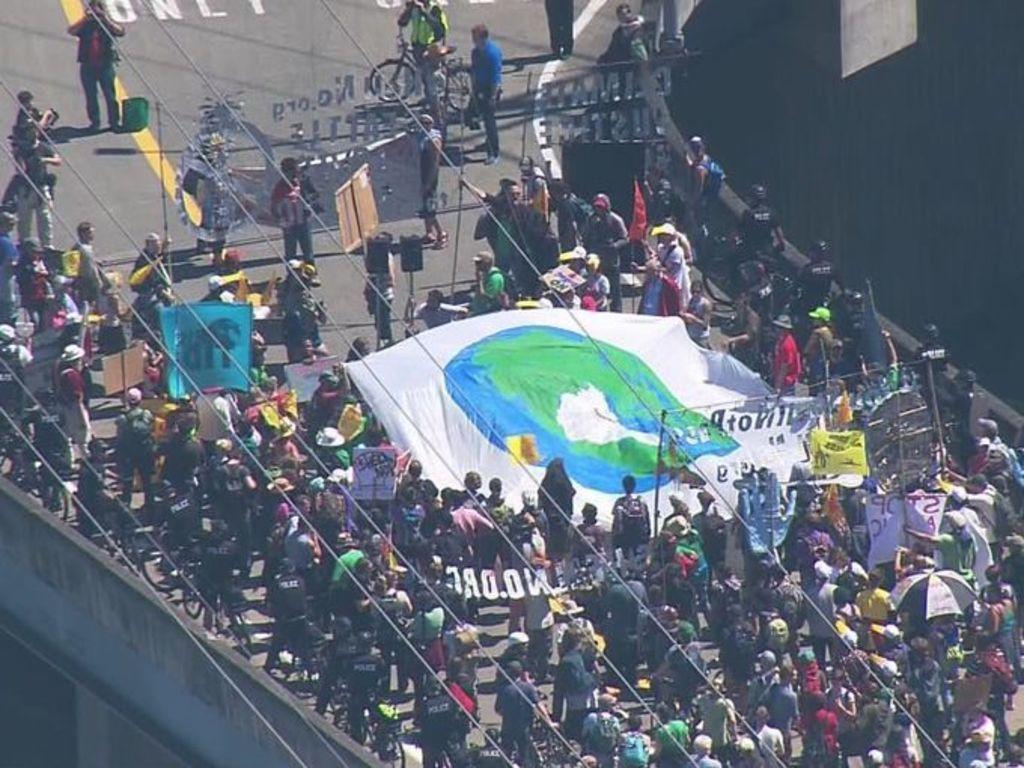Could you give a brief overview of what you see in this image? In this image I can see group of people are standing on the road among them some are holding some objects in their hands. Here I can see a bicycle and other objects on the road. Here I can see a white color cloth. 